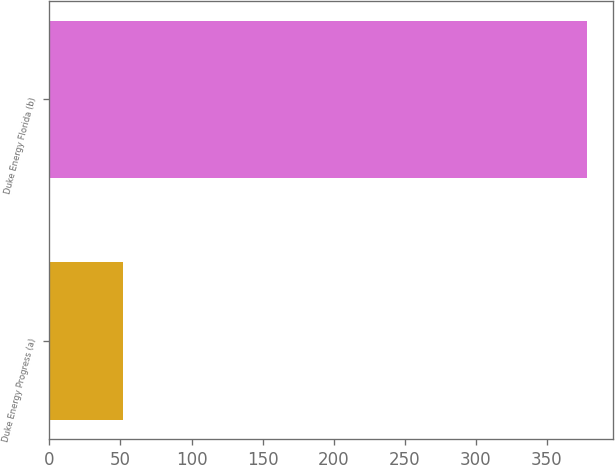Convert chart to OTSL. <chart><loc_0><loc_0><loc_500><loc_500><bar_chart><fcel>Duke Energy Progress (a)<fcel>Duke Energy Florida (b)<nl><fcel>52<fcel>378<nl></chart> 